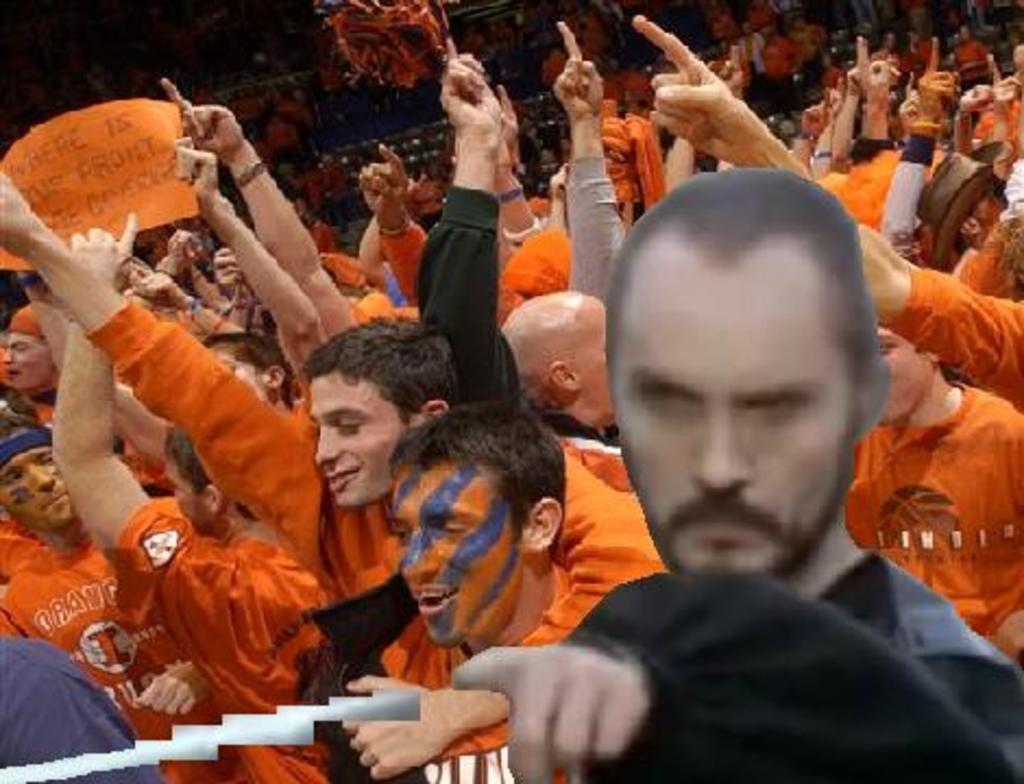Could you give a brief overview of what you see in this image? In this image, there are group of people wearing clothes and raising hands. There is a person on the left side of the image holding paper with his hands. 